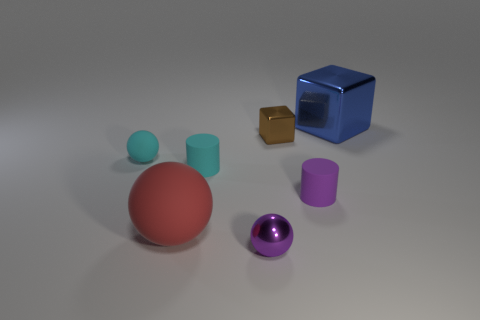Subtract all yellow balls. Subtract all red cylinders. How many balls are left? 3 Add 2 big red objects. How many objects exist? 9 Subtract all blocks. How many objects are left? 5 Add 2 brown blocks. How many brown blocks are left? 3 Add 5 green rubber spheres. How many green rubber spheres exist? 5 Subtract 0 brown balls. How many objects are left? 7 Subtract all green matte spheres. Subtract all blue blocks. How many objects are left? 6 